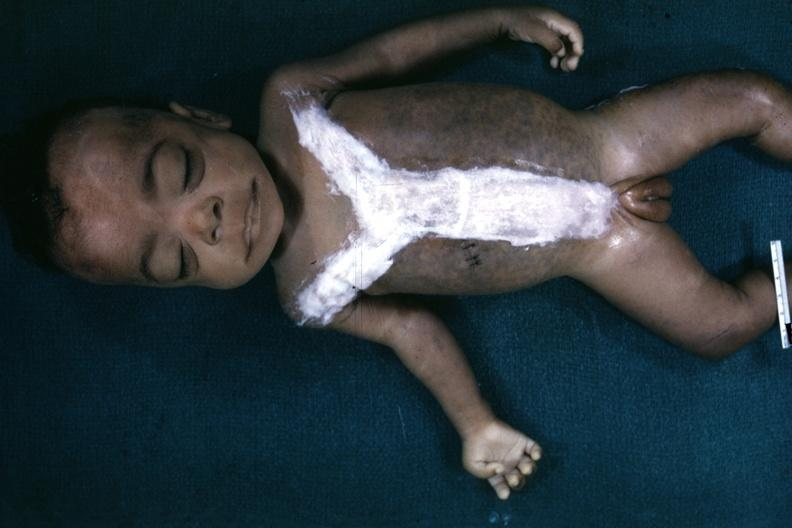how many hand is opened to show simian crease quite good example?
Answer the question using a single word or phrase. One 